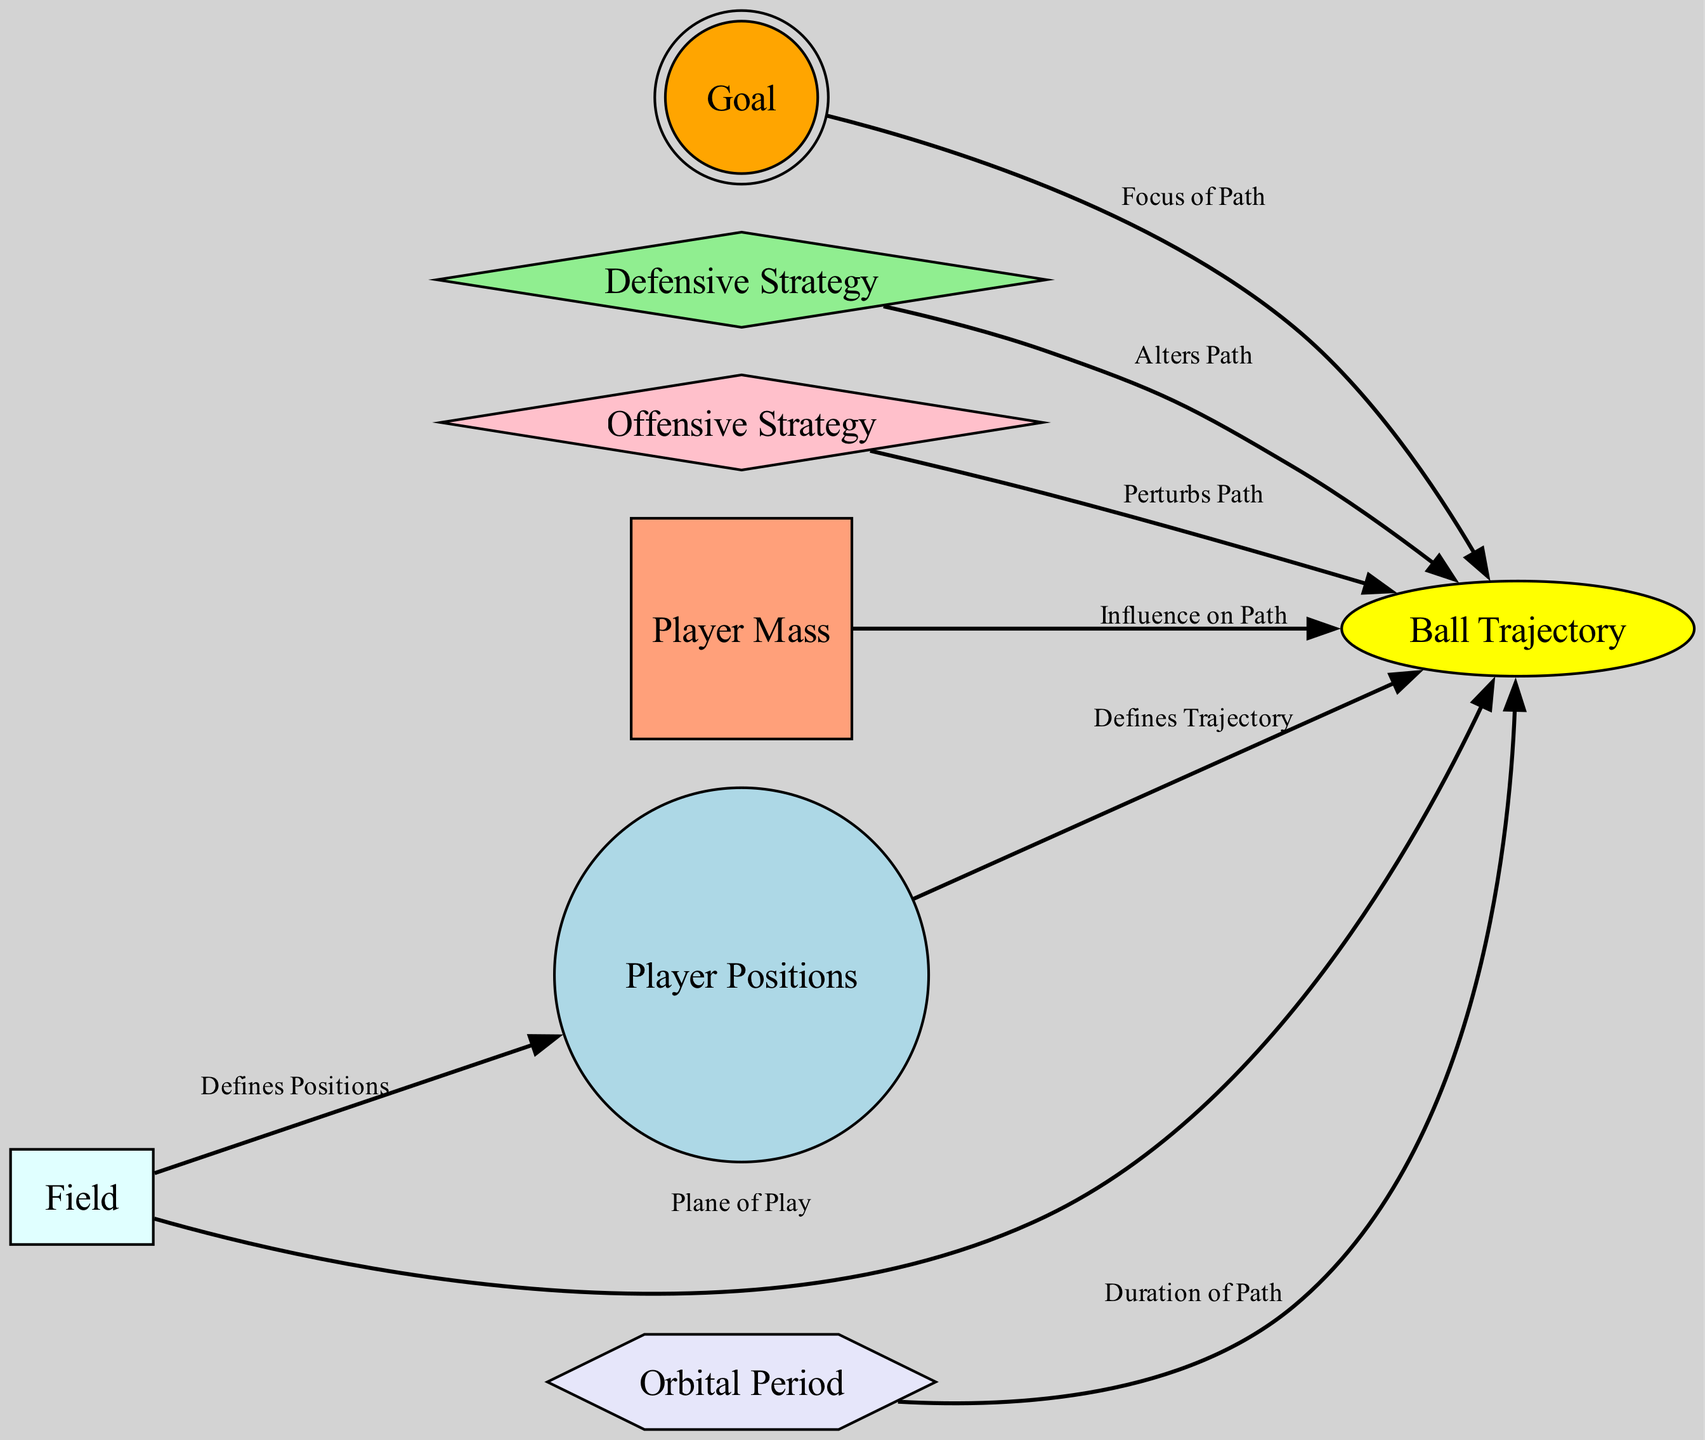What are the total number of nodes in the diagram? The diagram contains seven nodes: Player Positions, Ball Trajectory, Goal, Defensive Strategy, Offensive Strategy, Player Mass, and Field. Thus, the total count is 7.
Answer: 7 What is the color used for the Goal node? According to the color specifications given in the diagram, the Goal node has an orange fill color.
Answer: orange Which node represents the 'Influence on Path'? The Ball Trajectory node is influenced by Player Mass, which indicates its effect on the path of the ball as represented in the diagram.
Answer: Player Mass Which two strategies are categorized as 'diamond' shaped? The diagram indicates that both Defensive Strategy and Offensive Strategy are represented as diamond-shaped nodes. Therefore, these two strategies can be identified easily.
Answer: Defensive Strategy, Offensive Strategy What is the edge label connecting the Field to Player Positions? The connection from the Field to Player Positions is labeled 'Defines Positions,' indicating the relationship in the context of soccer positions.
Answer: Defines Positions How many edges are there in total? By summing the relationships provided in the edges section, we find that there are eight edges connecting the various nodes, outlining their interactions.
Answer: 8 Which node does the Ball Trajectory have the most connections to, and how many? Upon reviewing the edges, it is clear that the Ball Trajectory node connects to five different nodes (Player Positions, Goal, Defensive Strategy, Offensive Strategy, Player Mass), indicating its central role in the diagram.
Answer: 5 Which node can be seen as the 'Focus of Path'? The Goal node represents the focus around which the paths (or trajectories) of players and the ball circulate, similar to how planets orbit the sun.
Answer: Goal How does Offensive Strategy affect the Ball Trajectory? The diagram shows an edge labeled 'Perturbs Path' that connects Offensive Strategy to Ball Trajectory, meaning that offensive strategies lead to deviations or changes in the trajectory of the ball.
Answer: Perturbs Path 